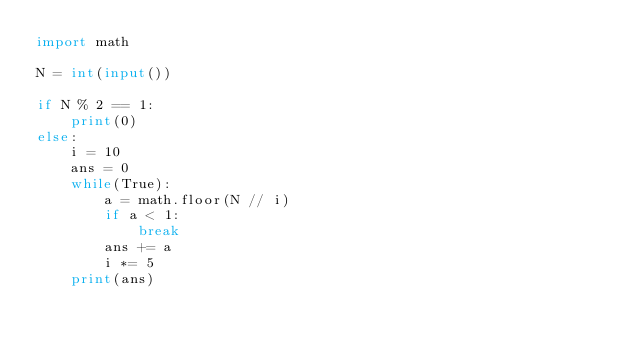Convert code to text. <code><loc_0><loc_0><loc_500><loc_500><_Python_>import math

N = int(input())

if N % 2 == 1:
    print(0)
else:
    i = 10
    ans = 0
    while(True):
        a = math.floor(N // i)
        if a < 1:
            break
        ans += a
        i *= 5
    print(ans)</code> 